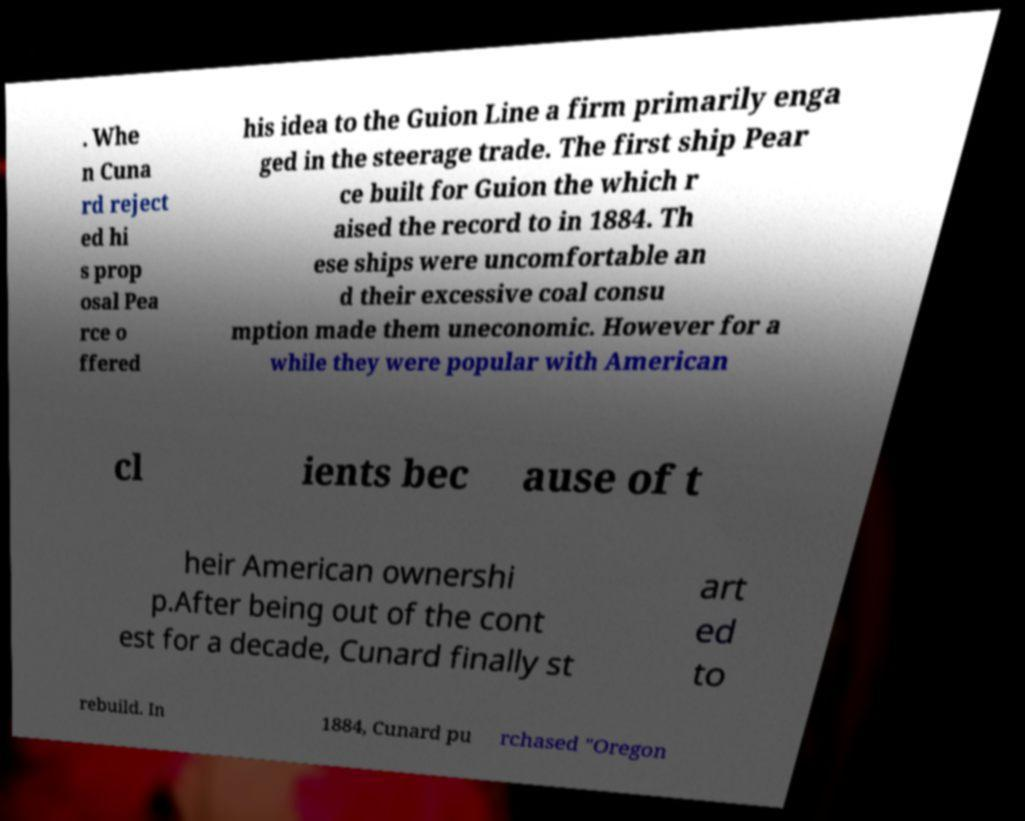Can you read and provide the text displayed in the image?This photo seems to have some interesting text. Can you extract and type it out for me? . Whe n Cuna rd reject ed hi s prop osal Pea rce o ffered his idea to the Guion Line a firm primarily enga ged in the steerage trade. The first ship Pear ce built for Guion the which r aised the record to in 1884. Th ese ships were uncomfortable an d their excessive coal consu mption made them uneconomic. However for a while they were popular with American cl ients bec ause of t heir American ownershi p.After being out of the cont est for a decade, Cunard finally st art ed to rebuild. In 1884, Cunard pu rchased "Oregon 